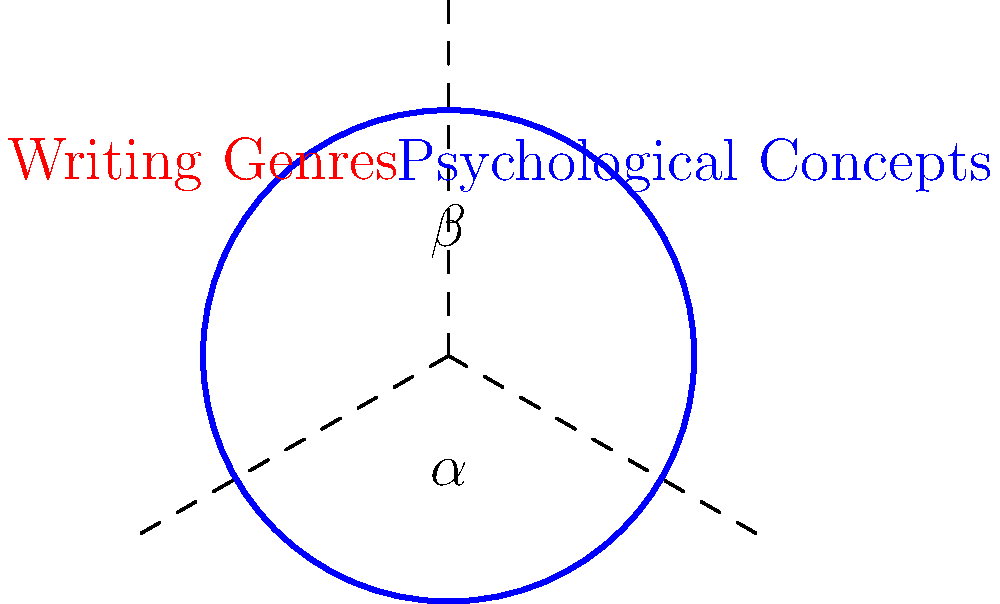In the Venn diagram above, which represents the overlap between writing genres and psychological concepts, what is the relationship between angles $\alpha$ and $\beta$? To determine the relationship between angles $\alpha$ and $\beta$, let's follow these steps:

1. Observe that the two circles in the Venn diagram are identical and intersect at two points, forming a symmetrical shape.

2. The center of both circles is at point O, and the dashed lines from O to A, B, and C form three radii of the circles.

3. In a circle, all radii are equal in length. Therefore, OA = OB = OC.

4. The triangle formed by OAB is thus an isosceles triangle, with OA = OB.

5. In an isosceles triangle, the angles opposite the equal sides are also equal. This means that angle AOC = angle BOC.

6. The angle at the center of a circle is twice the angle at the circumference when both angles intercept the same arc. Therefore, angle $\alpha$ at the center is twice the angle at A or B.

7. Angle $\beta$ is the angle between the two radii OA and OB.

8. Since angle AOC = angle BOC (from step 5), we can conclude that angle $\beta$ is twice angle $\alpha$.

Therefore, the relationship between angles $\alpha$ and $\beta$ is: $\beta = 2\alpha$.
Answer: $\beta = 2\alpha$ 